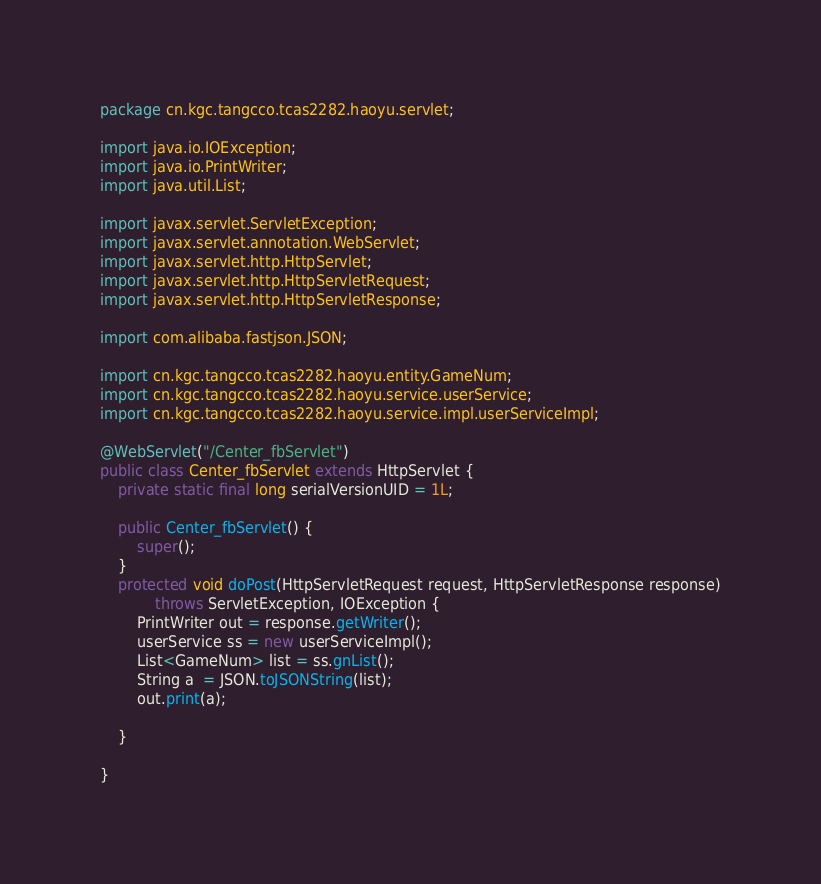Convert code to text. <code><loc_0><loc_0><loc_500><loc_500><_Java_>package cn.kgc.tangcco.tcas2282.haoyu.servlet;

import java.io.IOException;
import java.io.PrintWriter;
import java.util.List;

import javax.servlet.ServletException;
import javax.servlet.annotation.WebServlet;
import javax.servlet.http.HttpServlet;
import javax.servlet.http.HttpServletRequest;
import javax.servlet.http.HttpServletResponse;

import com.alibaba.fastjson.JSON;

import cn.kgc.tangcco.tcas2282.haoyu.entity.GameNum;
import cn.kgc.tangcco.tcas2282.haoyu.service.userService;
import cn.kgc.tangcco.tcas2282.haoyu.service.impl.userServiceImpl;

@WebServlet("/Center_fbServlet")
public class Center_fbServlet extends HttpServlet {
	private static final long serialVersionUID = 1L;

	public Center_fbServlet() {
		super();
	}
	protected void doPost(HttpServletRequest request, HttpServletResponse response)
			throws ServletException, IOException {
		PrintWriter out = response.getWriter();
		userService ss = new userServiceImpl();
		List<GameNum> list = ss.gnList();
		String a  = JSON.toJSONString(list);
		out.print(a);
		
	}

}
</code> 